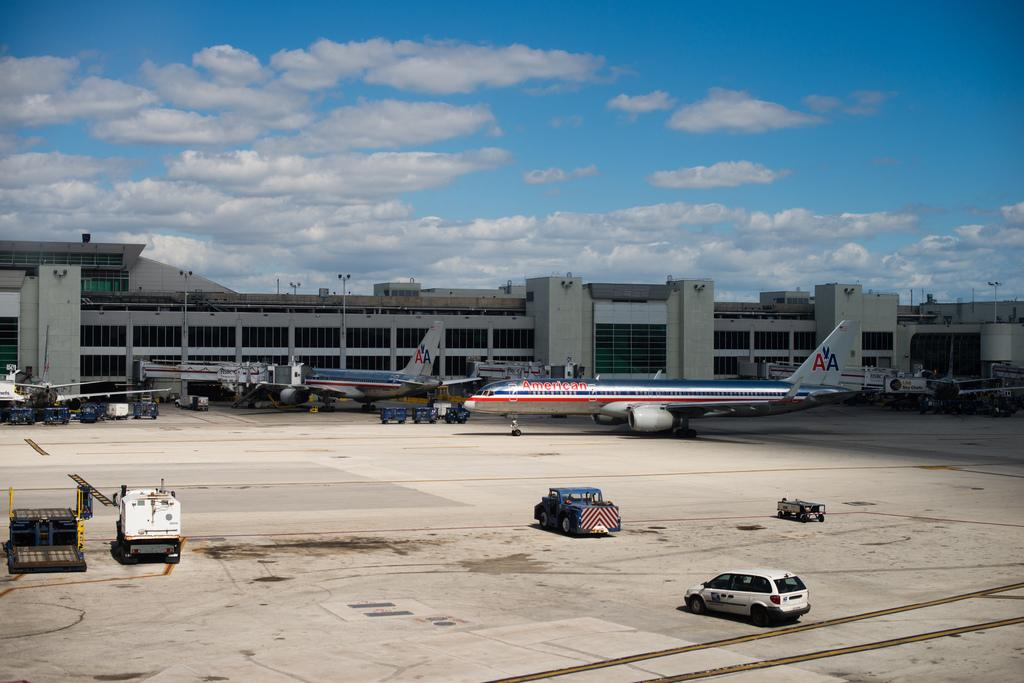What is the main subject of the image? The main subject of the image is aeroplanes. What else can be seen on the ground in the image? There are vehicles on the runway in the image. What is visible in the background of the image? There is a building in the background of the image. What is visible at the top of the image? The sky is visible at the top of the image, and clouds are present in the sky. What type of brush is being used to control the movement of the clouds in the image? There is no brush or control of clouds in the image; the clouds are a natural part of the sky. 